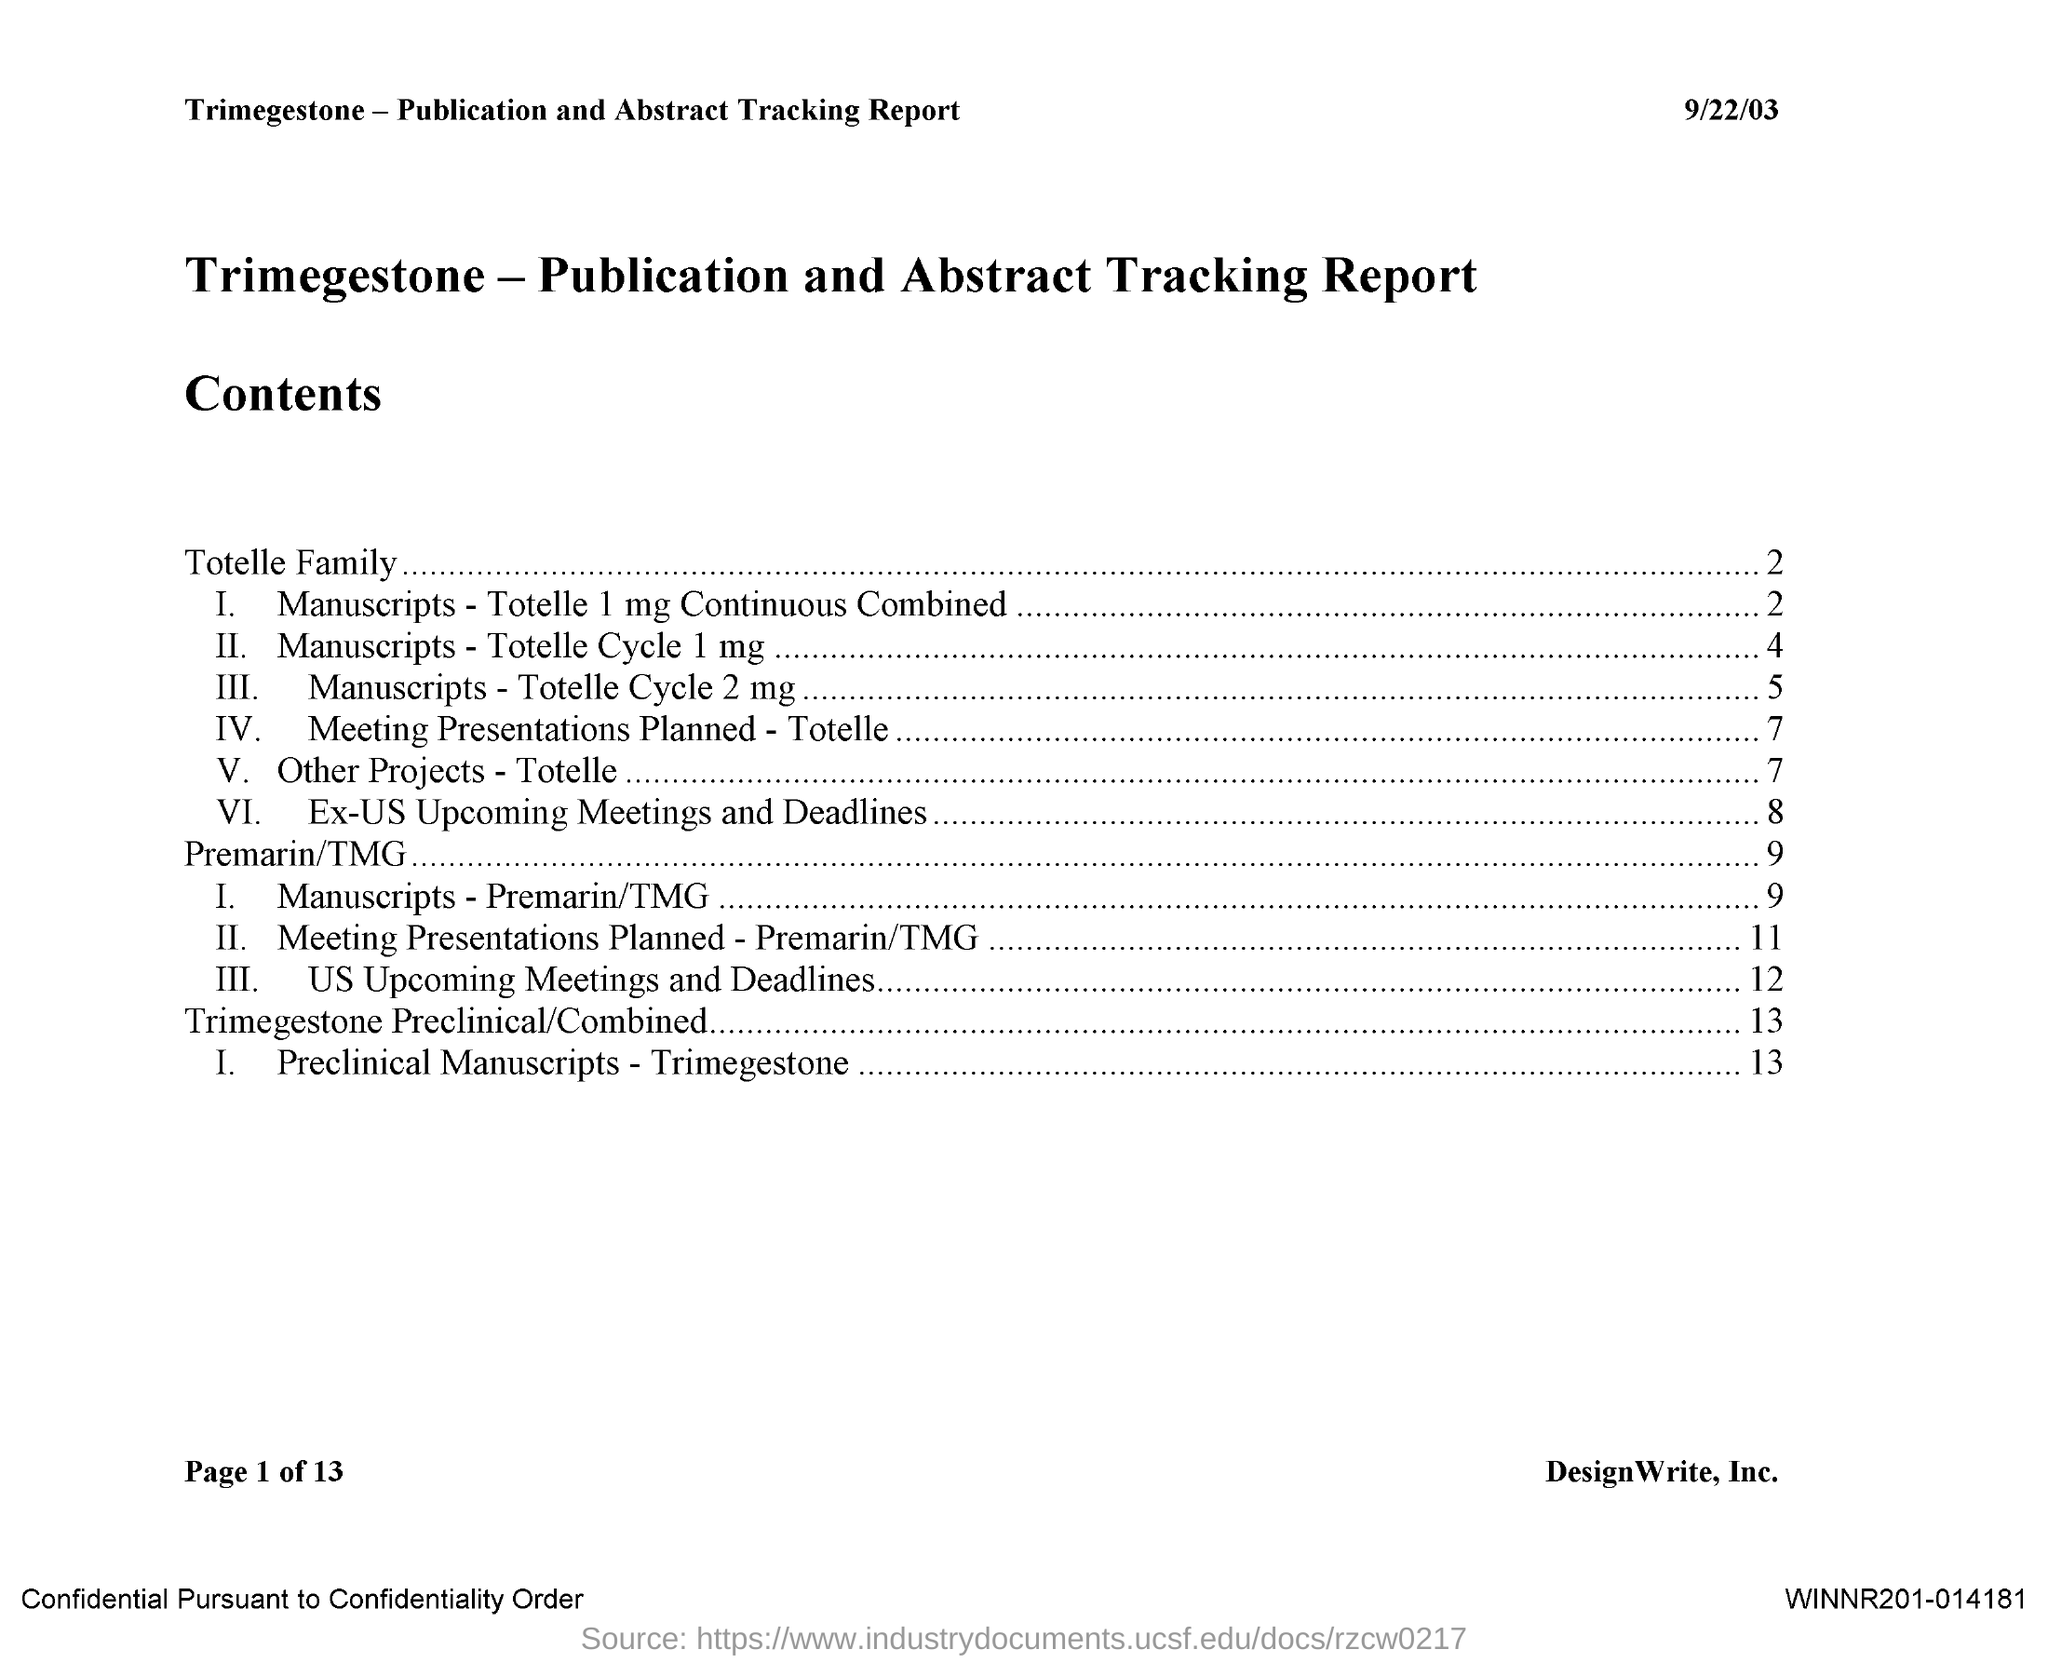What is the report about?
Your answer should be compact. Trimegestone - Publication and Abstract Tracking Report. What is the first main content?
Your answer should be very brief. Totelle Family. What is the second main content?
Ensure brevity in your answer.  Premarin/TMG. What is the third main content?
Offer a very short reply. Trimegestone Preclinical/combined. What is the first subdivision of Totelle Family?
Keep it short and to the point. Manuscripts - Totelle 1 mg Continuous Combined. What is the second subdivision of Totelle Family?
Your answer should be very brief. Manuscripts-Totelle Cycle  1mg. What is the third subdivision of Totelle Family?
Make the answer very short. Manuscripts-Totelle Cycle 2mg. What is the fourth subdivision of Totelle Family?
Offer a very short reply. Meeting Presentations Planned - Totelle. 